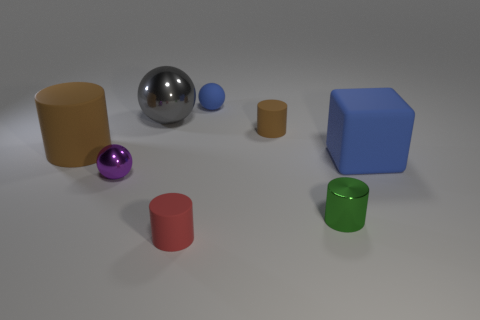Subtract 1 cylinders. How many cylinders are left? 3 Add 2 purple metal balls. How many objects exist? 10 Subtract all blocks. How many objects are left? 7 Add 1 large brown cylinders. How many large brown cylinders exist? 2 Subtract 1 green cylinders. How many objects are left? 7 Subtract all gray metallic things. Subtract all blue cubes. How many objects are left? 6 Add 3 big metal spheres. How many big metal spheres are left? 4 